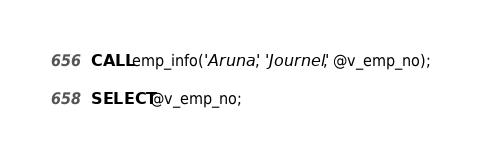Convert code to text. <code><loc_0><loc_0><loc_500><loc_500><_SQL_>CALL emp_info('Aruna', 'Journel', @v_emp_no);

SELECT @v_emp_no;
</code> 